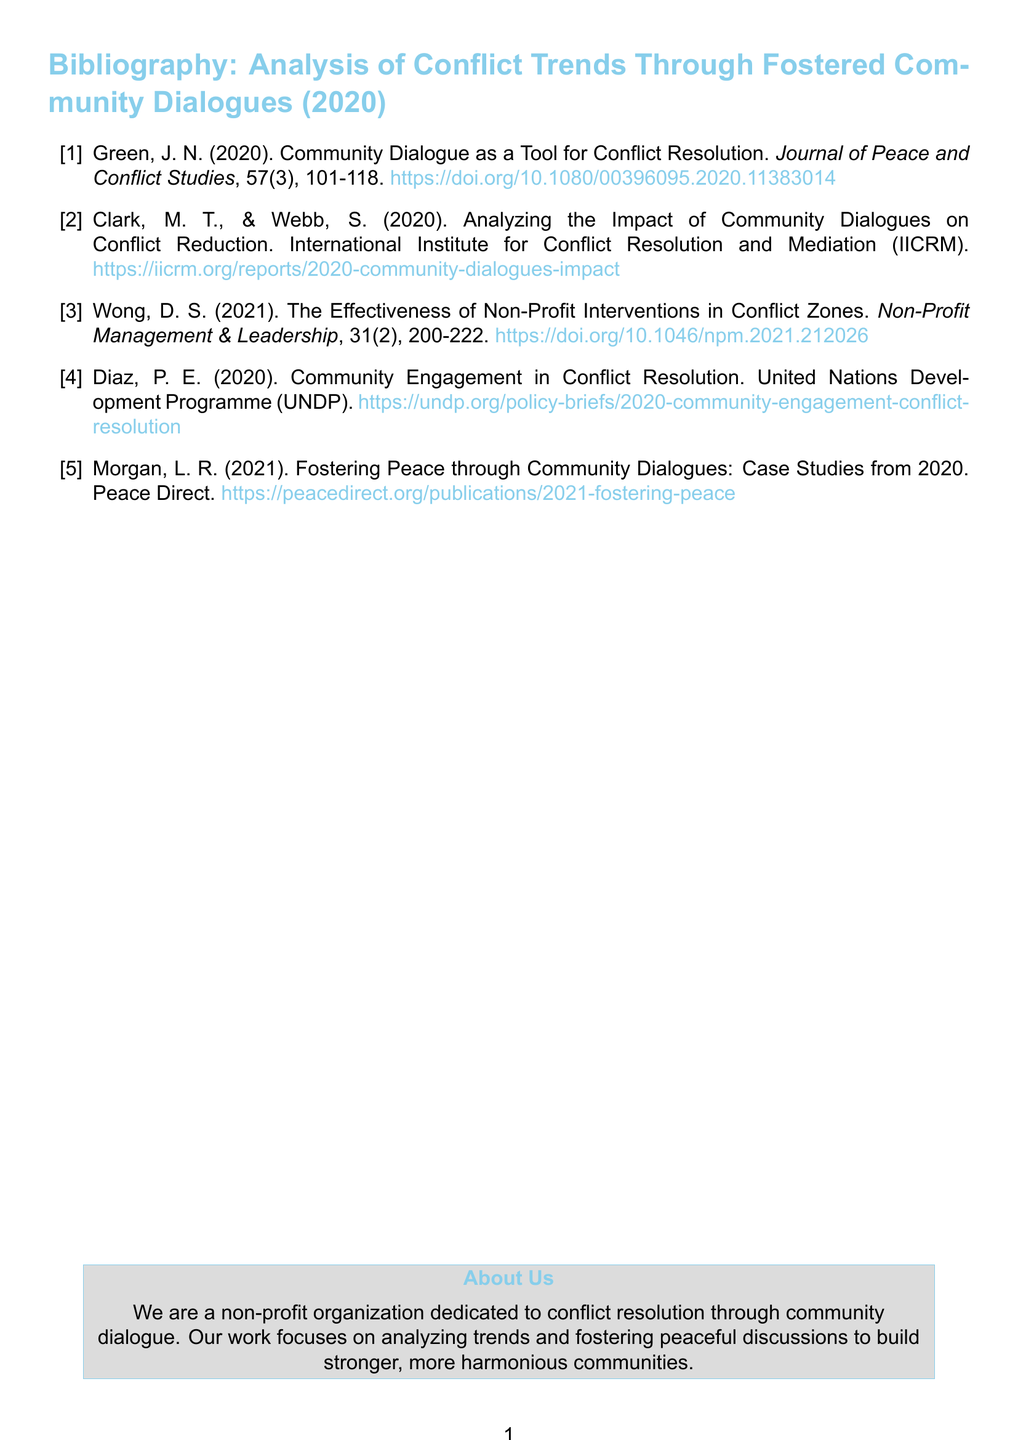What is the title of the first referenced article? The title of the first referenced article is found in the bibliographic entry, which is "Community Dialogue as a Tool for Conflict Resolution."
Answer: Community Dialogue as a Tool for Conflict Resolution Who are the authors of the second cited work? The authors of the second cited work are listed in the entry, which states "Clark, M. T., & Webb, S."
Answer: Clark, M. T., & Webb, S What year was the "Community Engagement in Conflict Resolution" published? The year of publication is indicated in the bibliographic entry for the work, which is 2020.
Answer: 2020 How many articles are authored by individuals with the last name starting with 'M'? The count of articles authored by individuals with the last name 'M' can be found by examining the entries, where Morgan is the only author and there is one such article.
Answer: 1 What is the source of the report authored by Diaz? The source of the report authored by Diaz is provided in the bibliographic entry, which is the United Nations Development Programme (UNDP).
Answer: United Nations Development Programme (UNDP) What type of publication is the "Journal of Peace and Conflict Studies"? The type of publication can be inferred from the categorization present in the entry, which describes it as a journal.
Answer: Journal What is indicated about the organization in the "About Us" section? The "About Us" section outlines that the organization is dedicated to conflict resolution through community dialogue.
Answer: Dedicated to conflict resolution through community dialogue What color is used for the bibliography title? The color used for the bibliography title is mentioned in the formatting instructions, which states it is peacefulblue.
Answer: Peacefulblue 